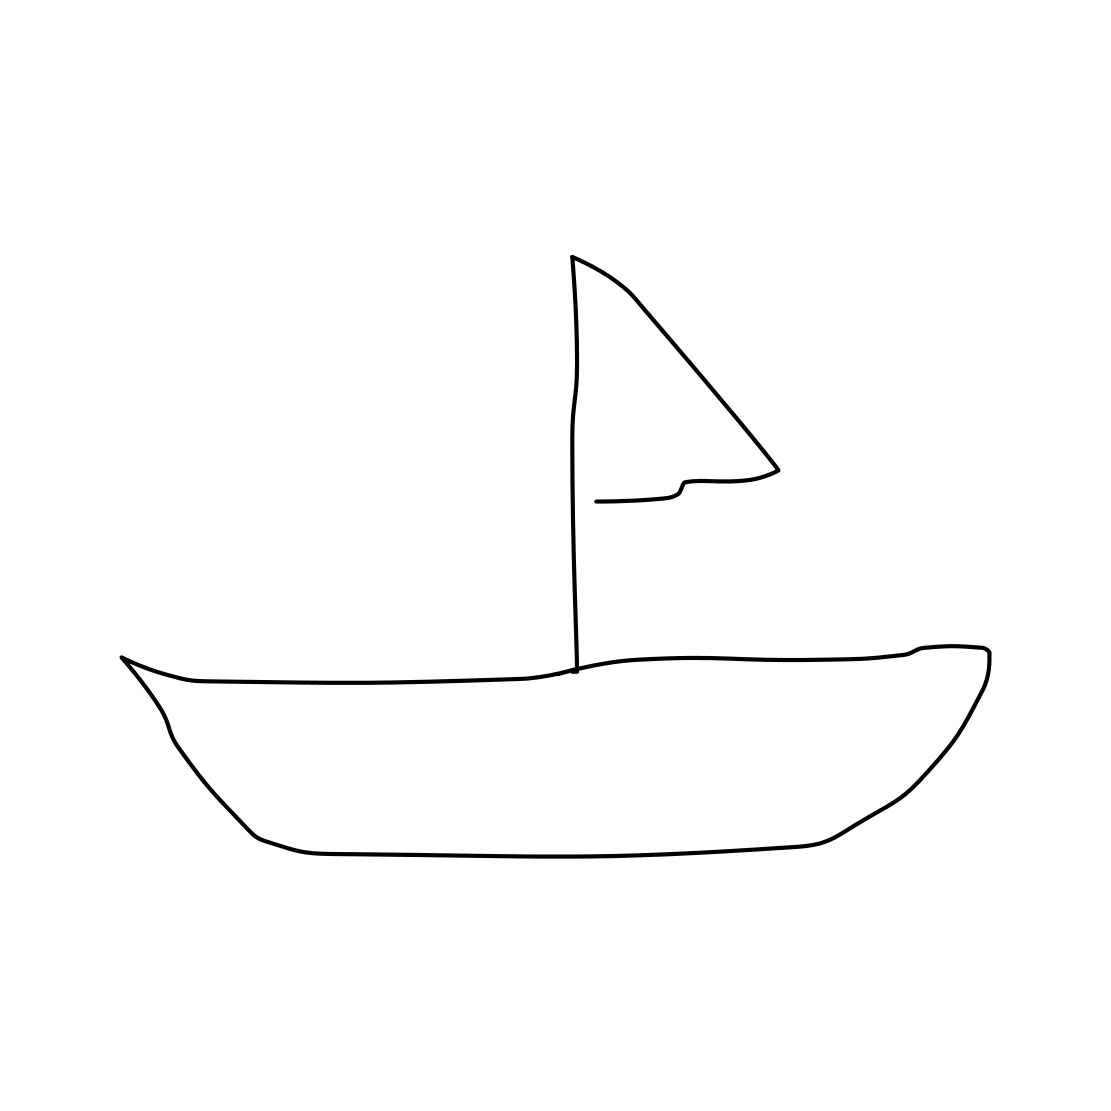What kind of setting do you think this sailboat would be found in? Given the simplicity of the drawing, the sailboat might be imagined on a calm lake or a peaceful day at sea with minimal wind—ideal for a leisurely sail. 